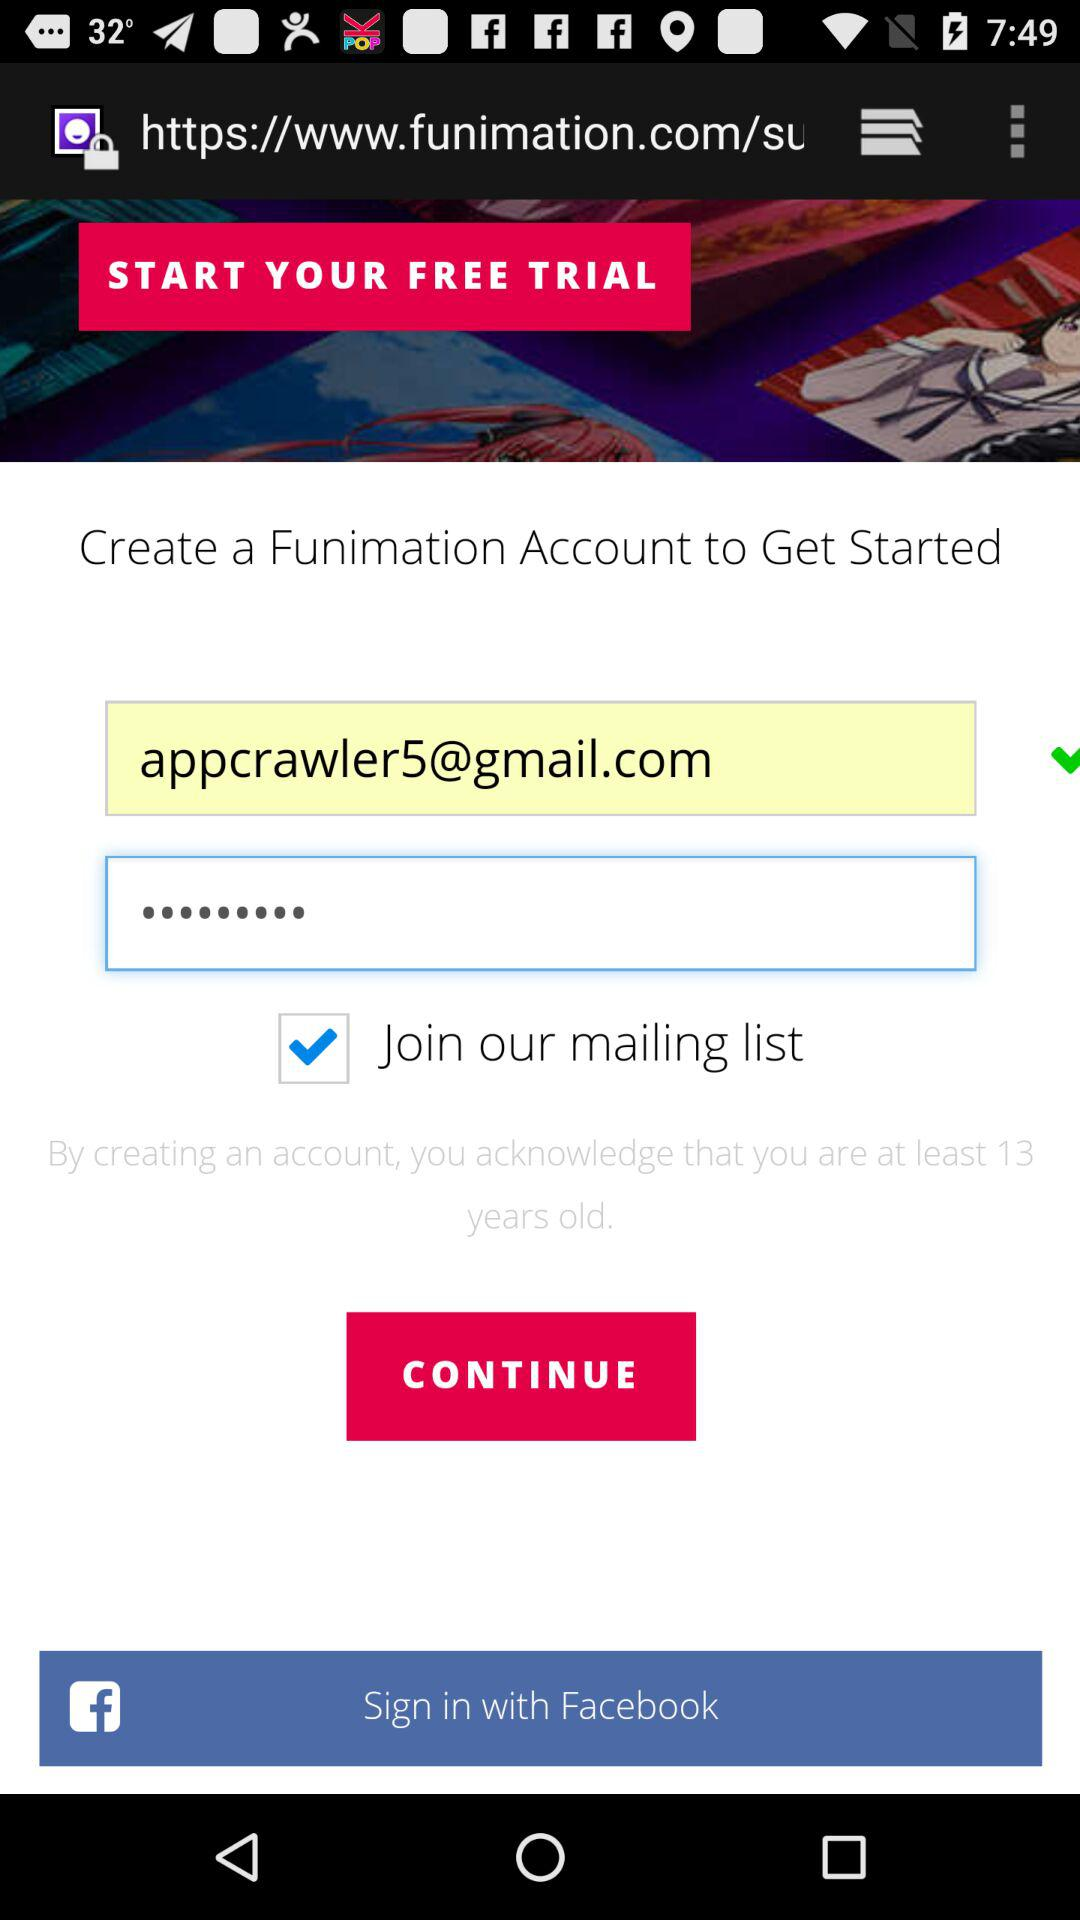What is the status of "Join our mailing list"? The status is "on". 